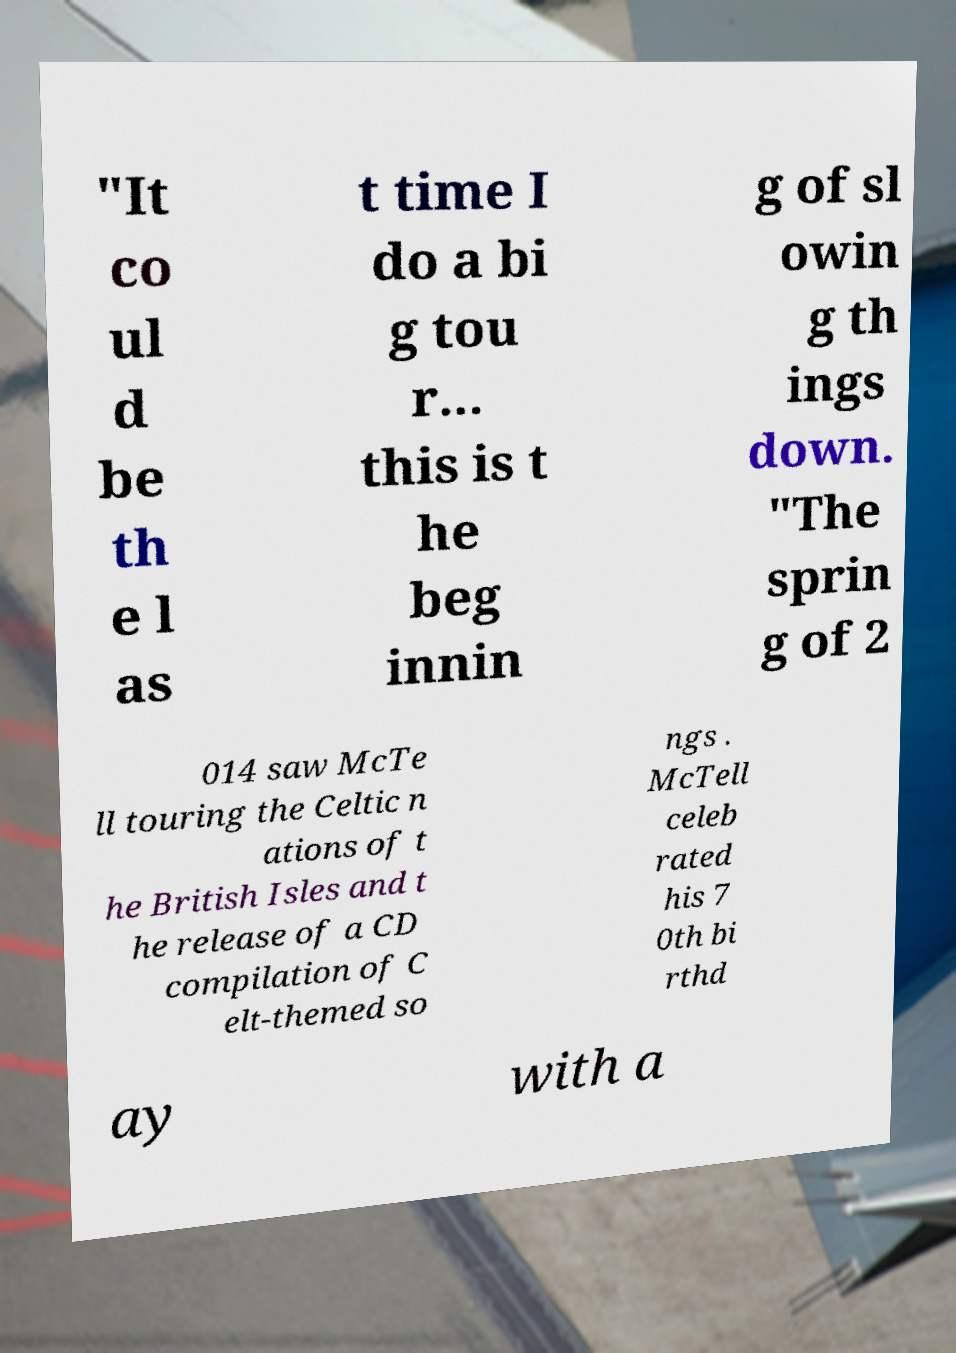For documentation purposes, I need the text within this image transcribed. Could you provide that? "It co ul d be th e l as t time I do a bi g tou r... this is t he beg innin g of sl owin g th ings down. "The sprin g of 2 014 saw McTe ll touring the Celtic n ations of t he British Isles and t he release of a CD compilation of C elt-themed so ngs . McTell celeb rated his 7 0th bi rthd ay with a 